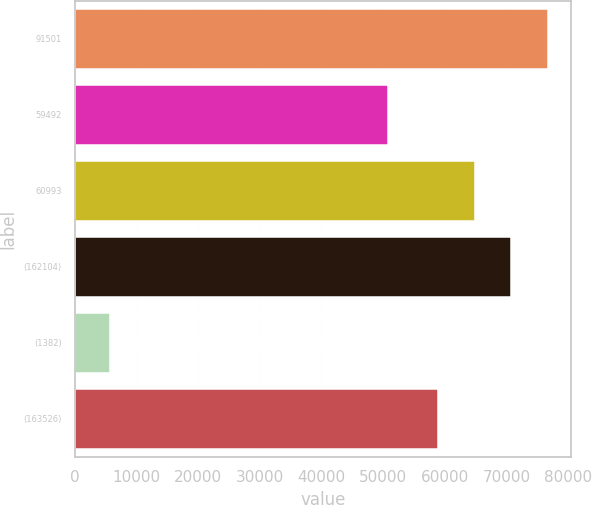Convert chart. <chart><loc_0><loc_0><loc_500><loc_500><bar_chart><fcel>91501<fcel>59492<fcel>60993<fcel>(162104)<fcel>(1382)<fcel>(163526)<nl><fcel>76706.4<fcel>50798<fcel>64864.8<fcel>70785.6<fcel>5659<fcel>58944<nl></chart> 